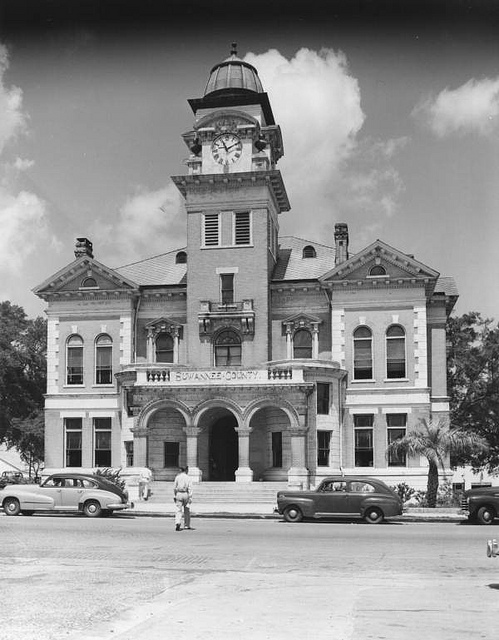<image>What might this building be called? It is unknown. The building might be a church, office, town hall, courthouse, city hall, clock tower, or house. What is this building called? I am unsure about the name of the building. It could be called 'county office', 'city hall', 'courthouse', 'church', 'mansion', 'office', or 'suwannee county courthouse'. What is this building called? This building is called Suwannee County Courthouse. What might this building be called? It is difficult to determine the name of the building. It can be called 'church', 'office', 'town hall', 'courthouse', 'city hall', 'clock tower', 'house' or none of these. 